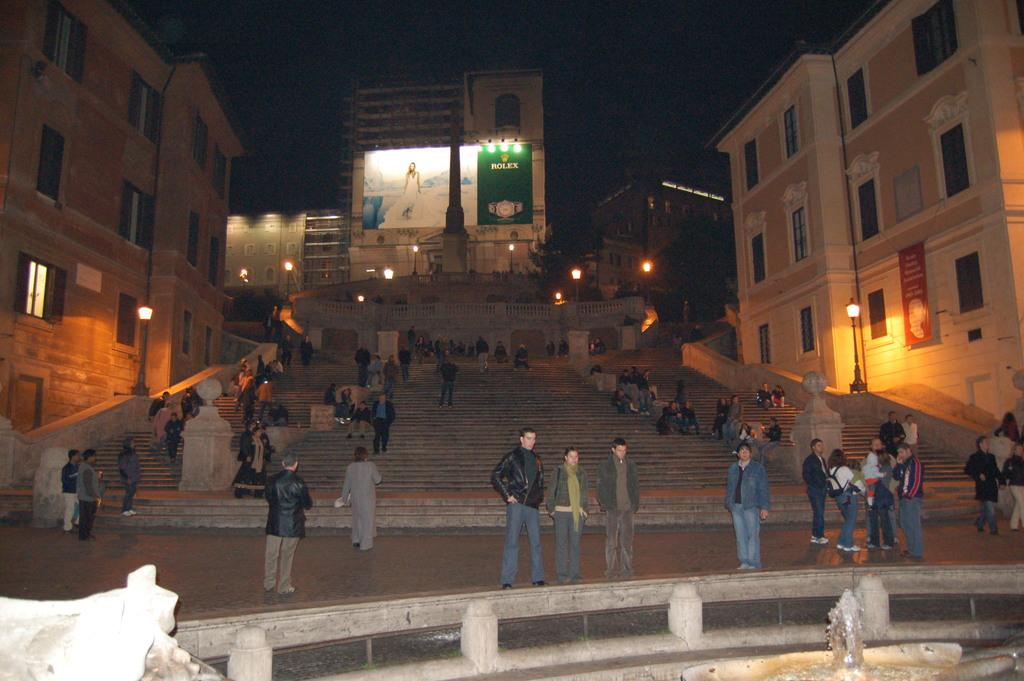What is happening in the middle of the image? There are people standing in the middle of the image. What can be seen at the top of the image? There is an advertising image at the top of the image. What type of structures are on either side of the advertising image? There are buildings on either side of the advertising image. Can you tell me how many flowers are in the image? There is no mention of flowers in the image, so it is not possible to determine their number. Is the person's aunt present in the image? There is no mention of an aunt or any specific person in the image, so it is not possible to determine if they are present. 